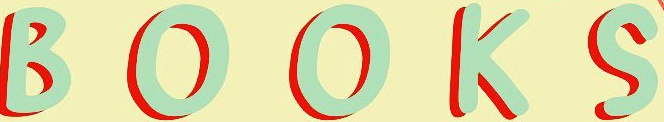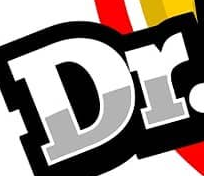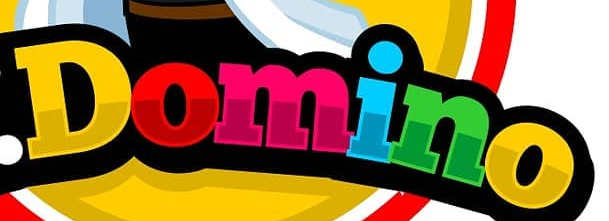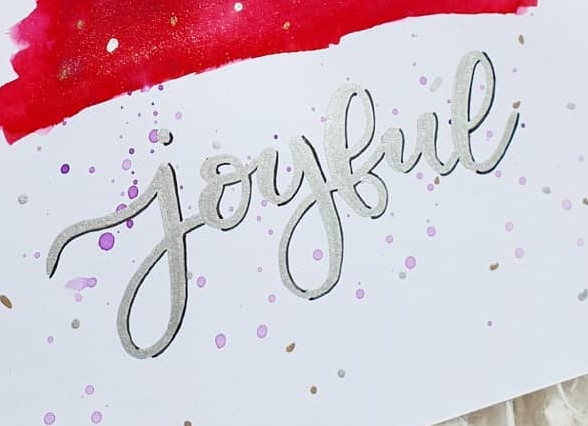Read the text from these images in sequence, separated by a semicolon. BOOKS; Dr; Domino; joybue 